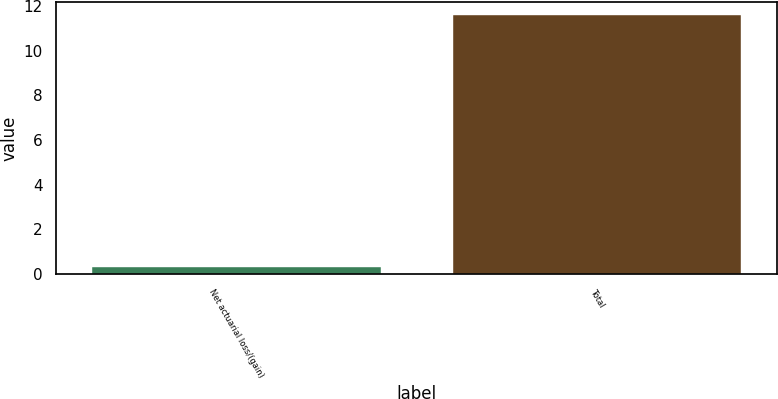Convert chart to OTSL. <chart><loc_0><loc_0><loc_500><loc_500><bar_chart><fcel>Net actuarial loss/(gain)<fcel>Total<nl><fcel>0.3<fcel>11.6<nl></chart> 